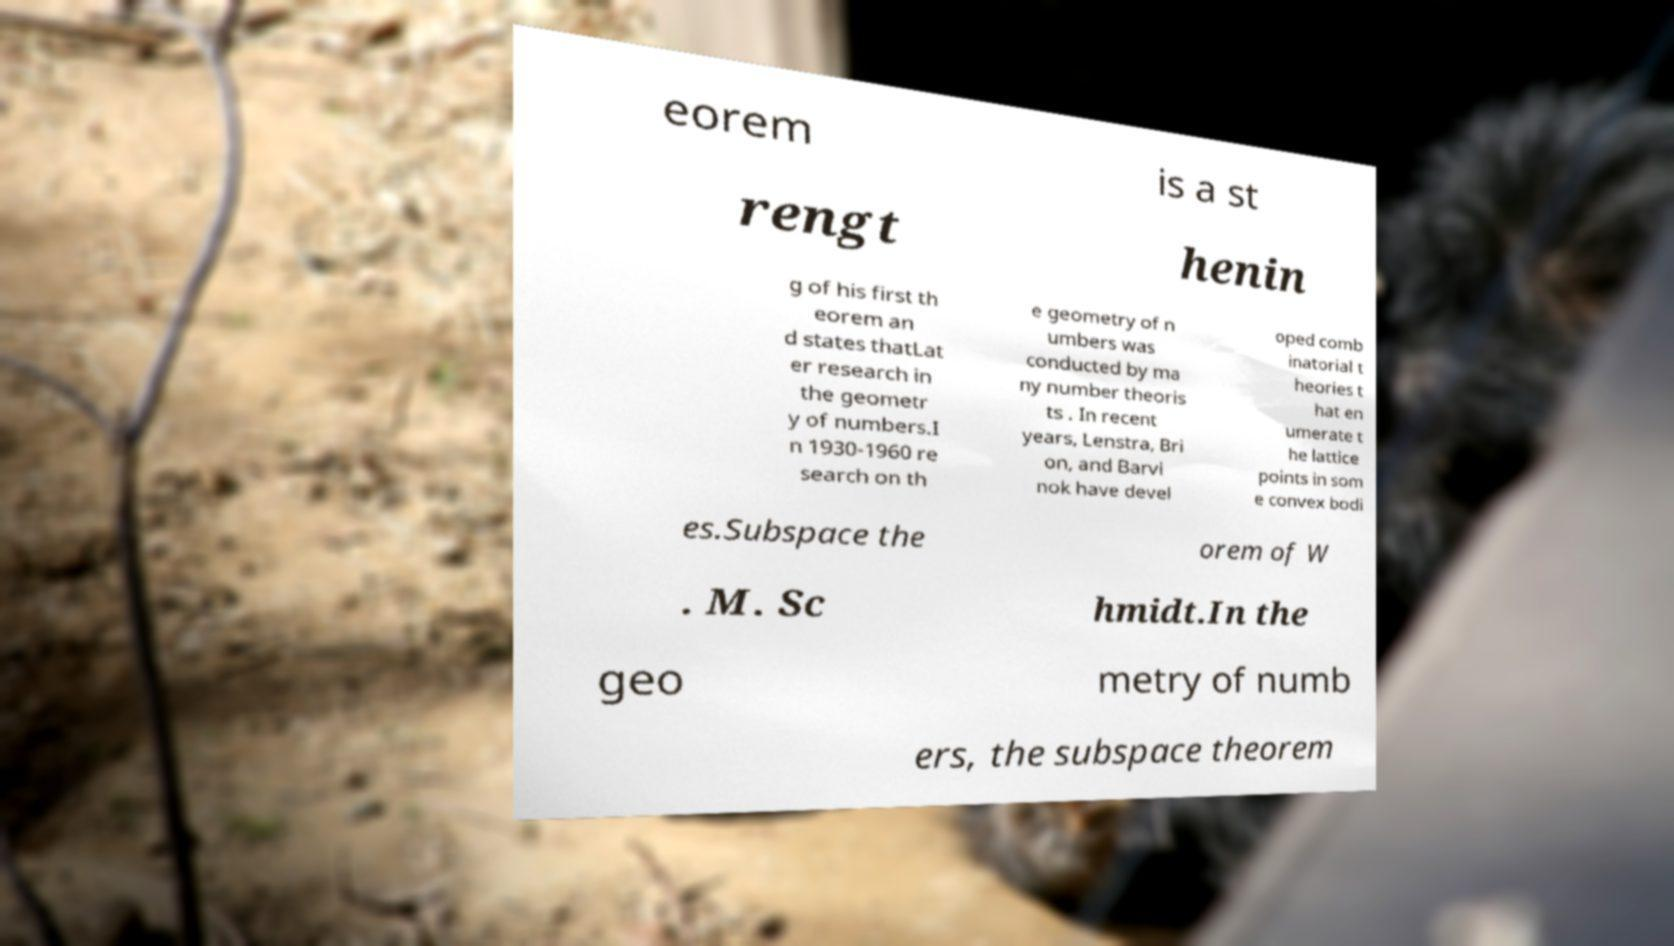For documentation purposes, I need the text within this image transcribed. Could you provide that? eorem is a st rengt henin g of his first th eorem an d states thatLat er research in the geometr y of numbers.I n 1930-1960 re search on th e geometry of n umbers was conducted by ma ny number theoris ts . In recent years, Lenstra, Bri on, and Barvi nok have devel oped comb inatorial t heories t hat en umerate t he lattice points in som e convex bodi es.Subspace the orem of W . M. Sc hmidt.In the geo metry of numb ers, the subspace theorem 